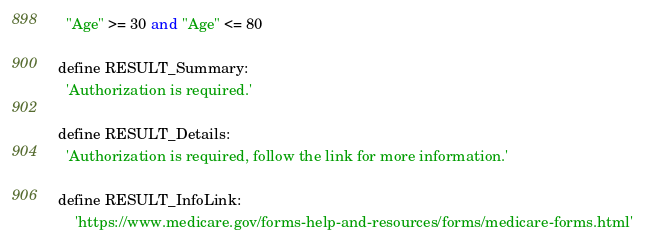Convert code to text. <code><loc_0><loc_0><loc_500><loc_500><_SQL_>  "Age" >= 30 and "Age" <= 80

define RESULT_Summary:
  'Authorization is required.'

define RESULT_Details:
  'Authorization is required, follow the link for more information.'

define RESULT_InfoLink:
    'https://www.medicare.gov/forms-help-and-resources/forms/medicare-forms.html'
</code> 